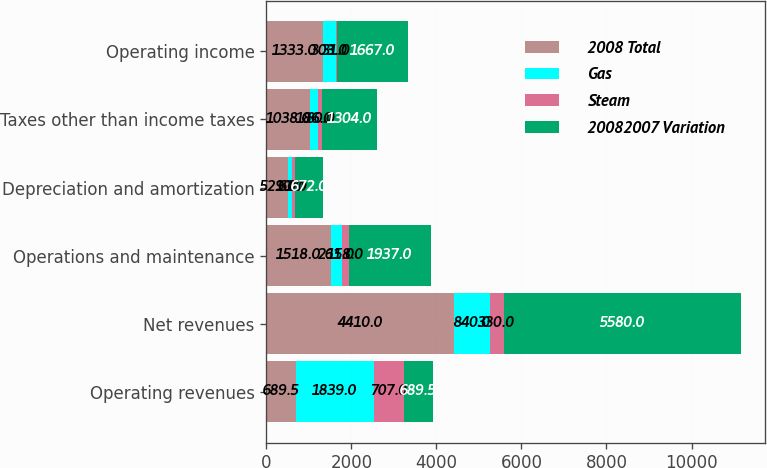Convert chart to OTSL. <chart><loc_0><loc_0><loc_500><loc_500><stacked_bar_chart><ecel><fcel>Operating revenues<fcel>Net revenues<fcel>Operations and maintenance<fcel>Depreciation and amortization<fcel>Taxes other than income taxes<fcel>Operating income<nl><fcel>2008 Total<fcel>689.5<fcel>4410<fcel>1518<fcel>521<fcel>1038<fcel>1333<nl><fcel>Gas<fcel>1839<fcel>840<fcel>261<fcel>90<fcel>186<fcel>303<nl><fcel>Steam<fcel>707<fcel>330<fcel>158<fcel>61<fcel>80<fcel>31<nl><fcel>20082007 Variation<fcel>689.5<fcel>5580<fcel>1937<fcel>672<fcel>1304<fcel>1667<nl></chart> 